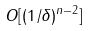<formula> <loc_0><loc_0><loc_500><loc_500>O [ ( 1 / \delta ) ^ { n - 2 } ]</formula> 